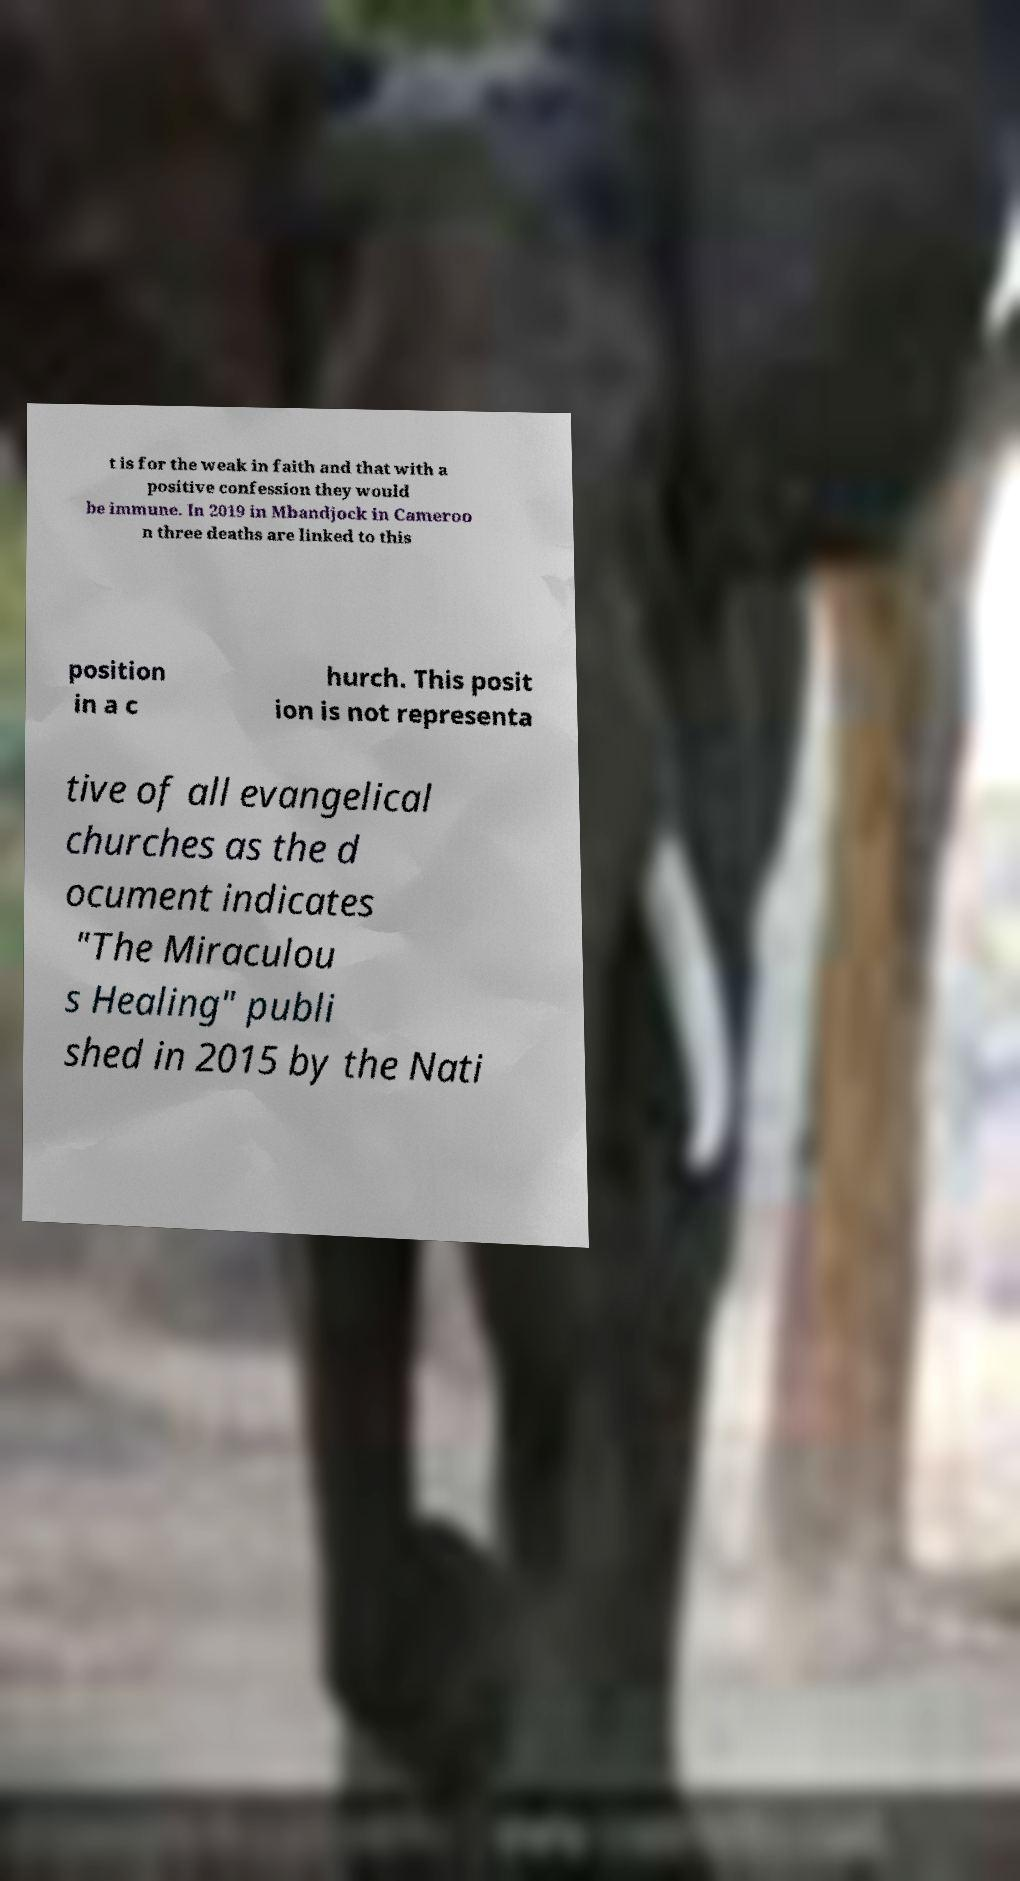For documentation purposes, I need the text within this image transcribed. Could you provide that? t is for the weak in faith and that with a positive confession they would be immune. In 2019 in Mbandjock in Cameroo n three deaths are linked to this position in a c hurch. This posit ion is not representa tive of all evangelical churches as the d ocument indicates "The Miraculou s Healing" publi shed in 2015 by the Nati 